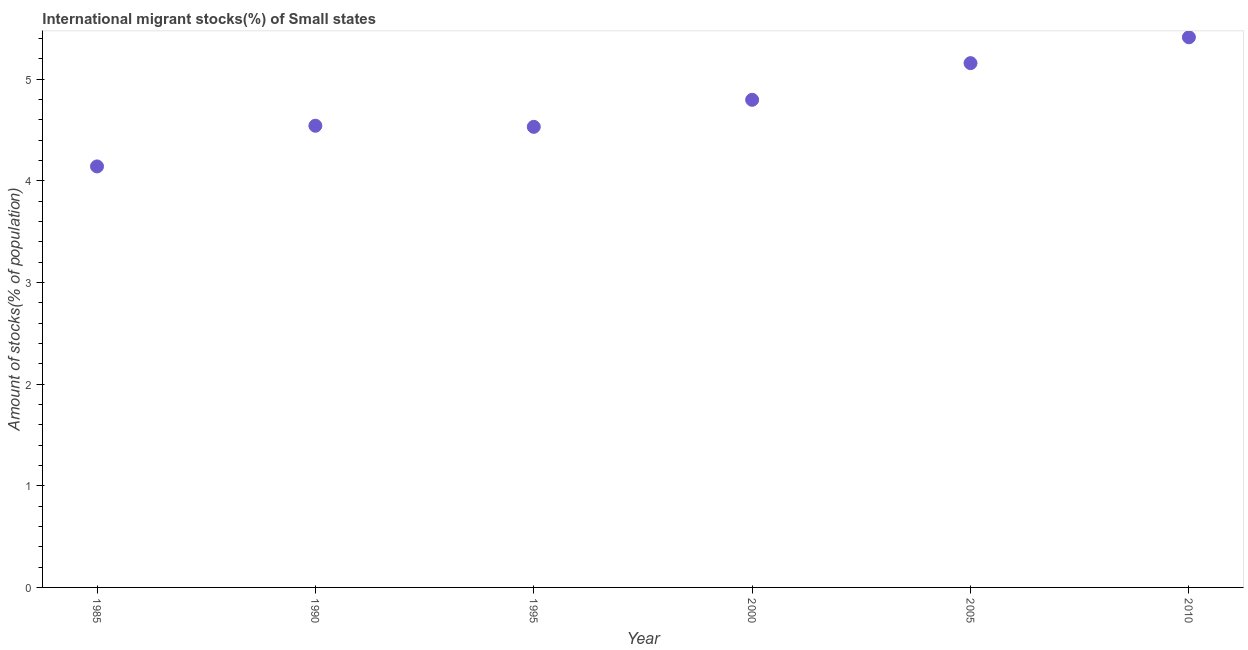What is the number of international migrant stocks in 1985?
Provide a succinct answer. 4.14. Across all years, what is the maximum number of international migrant stocks?
Your answer should be very brief. 5.41. Across all years, what is the minimum number of international migrant stocks?
Make the answer very short. 4.14. In which year was the number of international migrant stocks minimum?
Make the answer very short. 1985. What is the sum of the number of international migrant stocks?
Provide a short and direct response. 28.57. What is the difference between the number of international migrant stocks in 1985 and 2005?
Your answer should be very brief. -1.02. What is the average number of international migrant stocks per year?
Ensure brevity in your answer.  4.76. What is the median number of international migrant stocks?
Offer a terse response. 4.67. What is the ratio of the number of international migrant stocks in 1985 to that in 2010?
Give a very brief answer. 0.77. What is the difference between the highest and the second highest number of international migrant stocks?
Make the answer very short. 0.25. Is the sum of the number of international migrant stocks in 1995 and 2005 greater than the maximum number of international migrant stocks across all years?
Your answer should be very brief. Yes. What is the difference between the highest and the lowest number of international migrant stocks?
Offer a terse response. 1.27. In how many years, is the number of international migrant stocks greater than the average number of international migrant stocks taken over all years?
Provide a short and direct response. 3. How many dotlines are there?
Make the answer very short. 1. How many years are there in the graph?
Your answer should be compact. 6. What is the difference between two consecutive major ticks on the Y-axis?
Provide a succinct answer. 1. Are the values on the major ticks of Y-axis written in scientific E-notation?
Keep it short and to the point. No. Does the graph contain grids?
Offer a very short reply. No. What is the title of the graph?
Your answer should be very brief. International migrant stocks(%) of Small states. What is the label or title of the X-axis?
Your response must be concise. Year. What is the label or title of the Y-axis?
Your answer should be compact. Amount of stocks(% of population). What is the Amount of stocks(% of population) in 1985?
Keep it short and to the point. 4.14. What is the Amount of stocks(% of population) in 1990?
Make the answer very short. 4.54. What is the Amount of stocks(% of population) in 1995?
Your response must be concise. 4.53. What is the Amount of stocks(% of population) in 2000?
Your response must be concise. 4.8. What is the Amount of stocks(% of population) in 2005?
Ensure brevity in your answer.  5.16. What is the Amount of stocks(% of population) in 2010?
Make the answer very short. 5.41. What is the difference between the Amount of stocks(% of population) in 1985 and 1990?
Provide a short and direct response. -0.4. What is the difference between the Amount of stocks(% of population) in 1985 and 1995?
Provide a succinct answer. -0.39. What is the difference between the Amount of stocks(% of population) in 1985 and 2000?
Provide a short and direct response. -0.66. What is the difference between the Amount of stocks(% of population) in 1985 and 2005?
Your answer should be compact. -1.02. What is the difference between the Amount of stocks(% of population) in 1985 and 2010?
Keep it short and to the point. -1.27. What is the difference between the Amount of stocks(% of population) in 1990 and 1995?
Provide a short and direct response. 0.01. What is the difference between the Amount of stocks(% of population) in 1990 and 2000?
Your answer should be compact. -0.26. What is the difference between the Amount of stocks(% of population) in 1990 and 2005?
Give a very brief answer. -0.62. What is the difference between the Amount of stocks(% of population) in 1990 and 2010?
Offer a terse response. -0.87. What is the difference between the Amount of stocks(% of population) in 1995 and 2000?
Provide a short and direct response. -0.27. What is the difference between the Amount of stocks(% of population) in 1995 and 2005?
Your answer should be compact. -0.63. What is the difference between the Amount of stocks(% of population) in 1995 and 2010?
Keep it short and to the point. -0.88. What is the difference between the Amount of stocks(% of population) in 2000 and 2005?
Offer a terse response. -0.36. What is the difference between the Amount of stocks(% of population) in 2000 and 2010?
Give a very brief answer. -0.61. What is the difference between the Amount of stocks(% of population) in 2005 and 2010?
Give a very brief answer. -0.25. What is the ratio of the Amount of stocks(% of population) in 1985 to that in 1990?
Keep it short and to the point. 0.91. What is the ratio of the Amount of stocks(% of population) in 1985 to that in 1995?
Provide a succinct answer. 0.91. What is the ratio of the Amount of stocks(% of population) in 1985 to that in 2000?
Offer a very short reply. 0.86. What is the ratio of the Amount of stocks(% of population) in 1985 to that in 2005?
Give a very brief answer. 0.8. What is the ratio of the Amount of stocks(% of population) in 1985 to that in 2010?
Your answer should be very brief. 0.77. What is the ratio of the Amount of stocks(% of population) in 1990 to that in 2000?
Give a very brief answer. 0.95. What is the ratio of the Amount of stocks(% of population) in 1990 to that in 2005?
Your response must be concise. 0.88. What is the ratio of the Amount of stocks(% of population) in 1990 to that in 2010?
Ensure brevity in your answer.  0.84. What is the ratio of the Amount of stocks(% of population) in 1995 to that in 2000?
Offer a terse response. 0.94. What is the ratio of the Amount of stocks(% of population) in 1995 to that in 2005?
Provide a short and direct response. 0.88. What is the ratio of the Amount of stocks(% of population) in 1995 to that in 2010?
Your response must be concise. 0.84. What is the ratio of the Amount of stocks(% of population) in 2000 to that in 2010?
Make the answer very short. 0.89. What is the ratio of the Amount of stocks(% of population) in 2005 to that in 2010?
Provide a succinct answer. 0.95. 